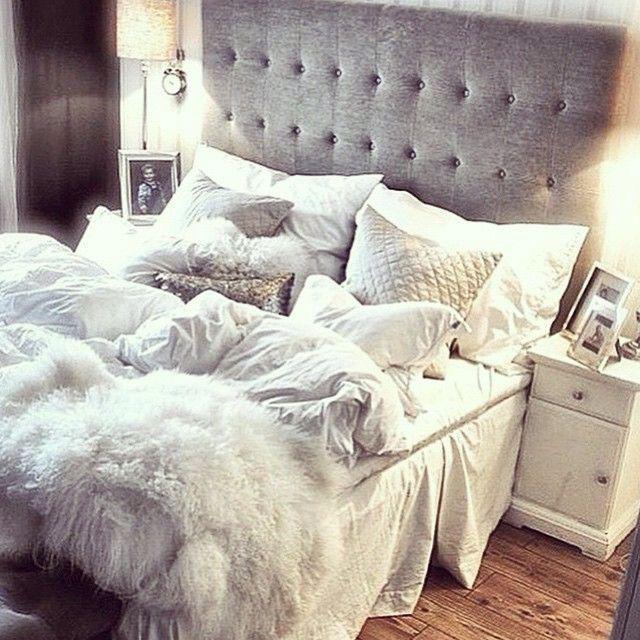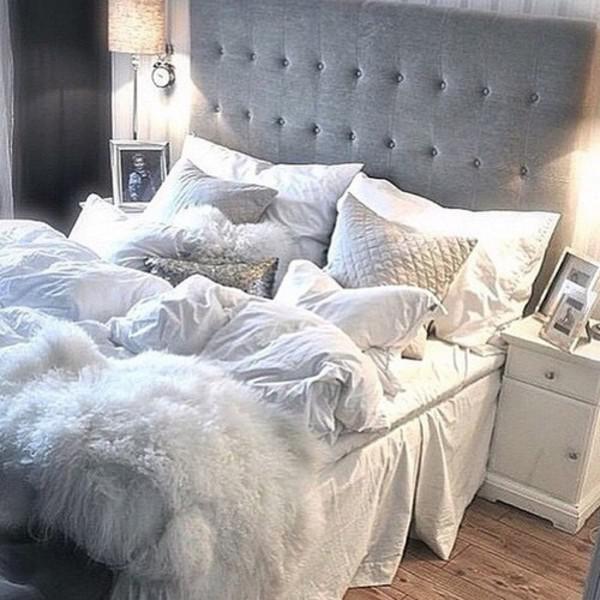The first image is the image on the left, the second image is the image on the right. For the images shown, is this caption "At least one of the beds has a grey headboard." true? Answer yes or no. Yes. 